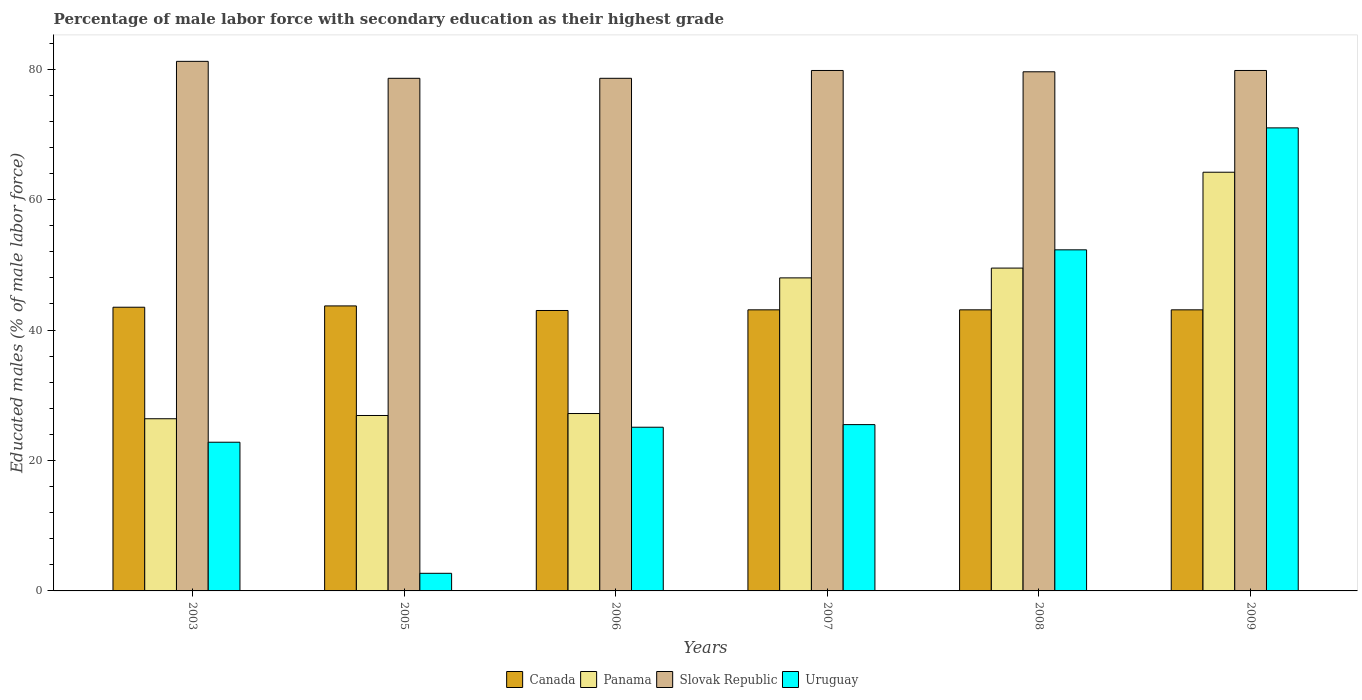How many different coloured bars are there?
Your response must be concise. 4. Are the number of bars per tick equal to the number of legend labels?
Your answer should be compact. Yes. In how many cases, is the number of bars for a given year not equal to the number of legend labels?
Ensure brevity in your answer.  0. What is the percentage of male labor force with secondary education in Panama in 2003?
Provide a short and direct response. 26.4. Across all years, what is the maximum percentage of male labor force with secondary education in Slovak Republic?
Offer a terse response. 81.2. Across all years, what is the minimum percentage of male labor force with secondary education in Slovak Republic?
Your response must be concise. 78.6. In which year was the percentage of male labor force with secondary education in Uruguay minimum?
Offer a terse response. 2005. What is the total percentage of male labor force with secondary education in Canada in the graph?
Your response must be concise. 259.5. What is the difference between the percentage of male labor force with secondary education in Panama in 2006 and that in 2008?
Provide a succinct answer. -22.3. What is the difference between the percentage of male labor force with secondary education in Panama in 2008 and the percentage of male labor force with secondary education in Slovak Republic in 2003?
Keep it short and to the point. -31.7. What is the average percentage of male labor force with secondary education in Slovak Republic per year?
Provide a short and direct response. 79.6. What is the ratio of the percentage of male labor force with secondary education in Slovak Republic in 2003 to that in 2008?
Keep it short and to the point. 1.02. What is the difference between the highest and the second highest percentage of male labor force with secondary education in Panama?
Offer a terse response. 14.7. What is the difference between the highest and the lowest percentage of male labor force with secondary education in Panama?
Provide a short and direct response. 37.8. In how many years, is the percentage of male labor force with secondary education in Panama greater than the average percentage of male labor force with secondary education in Panama taken over all years?
Make the answer very short. 3. What does the 4th bar from the left in 2006 represents?
Ensure brevity in your answer.  Uruguay. What does the 1st bar from the right in 2009 represents?
Your answer should be very brief. Uruguay. How many bars are there?
Your response must be concise. 24. Are all the bars in the graph horizontal?
Ensure brevity in your answer.  No. How many years are there in the graph?
Ensure brevity in your answer.  6. What is the difference between two consecutive major ticks on the Y-axis?
Your answer should be very brief. 20. Does the graph contain grids?
Provide a succinct answer. No. Where does the legend appear in the graph?
Offer a very short reply. Bottom center. How many legend labels are there?
Make the answer very short. 4. What is the title of the graph?
Ensure brevity in your answer.  Percentage of male labor force with secondary education as their highest grade. What is the label or title of the X-axis?
Your answer should be compact. Years. What is the label or title of the Y-axis?
Provide a short and direct response. Educated males (% of male labor force). What is the Educated males (% of male labor force) of Canada in 2003?
Provide a short and direct response. 43.5. What is the Educated males (% of male labor force) in Panama in 2003?
Offer a terse response. 26.4. What is the Educated males (% of male labor force) of Slovak Republic in 2003?
Your response must be concise. 81.2. What is the Educated males (% of male labor force) of Uruguay in 2003?
Make the answer very short. 22.8. What is the Educated males (% of male labor force) of Canada in 2005?
Ensure brevity in your answer.  43.7. What is the Educated males (% of male labor force) in Panama in 2005?
Make the answer very short. 26.9. What is the Educated males (% of male labor force) in Slovak Republic in 2005?
Provide a succinct answer. 78.6. What is the Educated males (% of male labor force) in Uruguay in 2005?
Your answer should be compact. 2.7. What is the Educated males (% of male labor force) in Panama in 2006?
Your answer should be very brief. 27.2. What is the Educated males (% of male labor force) of Slovak Republic in 2006?
Offer a terse response. 78.6. What is the Educated males (% of male labor force) in Uruguay in 2006?
Provide a short and direct response. 25.1. What is the Educated males (% of male labor force) of Canada in 2007?
Give a very brief answer. 43.1. What is the Educated males (% of male labor force) of Panama in 2007?
Provide a succinct answer. 48. What is the Educated males (% of male labor force) of Slovak Republic in 2007?
Offer a very short reply. 79.8. What is the Educated males (% of male labor force) in Uruguay in 2007?
Offer a very short reply. 25.5. What is the Educated males (% of male labor force) in Canada in 2008?
Ensure brevity in your answer.  43.1. What is the Educated males (% of male labor force) in Panama in 2008?
Provide a short and direct response. 49.5. What is the Educated males (% of male labor force) of Slovak Republic in 2008?
Your response must be concise. 79.6. What is the Educated males (% of male labor force) in Uruguay in 2008?
Your answer should be compact. 52.3. What is the Educated males (% of male labor force) of Canada in 2009?
Provide a short and direct response. 43.1. What is the Educated males (% of male labor force) of Panama in 2009?
Your answer should be very brief. 64.2. What is the Educated males (% of male labor force) in Slovak Republic in 2009?
Offer a very short reply. 79.8. Across all years, what is the maximum Educated males (% of male labor force) in Canada?
Offer a very short reply. 43.7. Across all years, what is the maximum Educated males (% of male labor force) in Panama?
Offer a very short reply. 64.2. Across all years, what is the maximum Educated males (% of male labor force) in Slovak Republic?
Your response must be concise. 81.2. Across all years, what is the maximum Educated males (% of male labor force) of Uruguay?
Your answer should be very brief. 71. Across all years, what is the minimum Educated males (% of male labor force) in Canada?
Give a very brief answer. 43. Across all years, what is the minimum Educated males (% of male labor force) of Panama?
Your answer should be compact. 26.4. Across all years, what is the minimum Educated males (% of male labor force) of Slovak Republic?
Offer a very short reply. 78.6. Across all years, what is the minimum Educated males (% of male labor force) in Uruguay?
Provide a succinct answer. 2.7. What is the total Educated males (% of male labor force) of Canada in the graph?
Provide a short and direct response. 259.5. What is the total Educated males (% of male labor force) of Panama in the graph?
Make the answer very short. 242.2. What is the total Educated males (% of male labor force) in Slovak Republic in the graph?
Give a very brief answer. 477.6. What is the total Educated males (% of male labor force) in Uruguay in the graph?
Make the answer very short. 199.4. What is the difference between the Educated males (% of male labor force) in Slovak Republic in 2003 and that in 2005?
Your response must be concise. 2.6. What is the difference between the Educated males (% of male labor force) of Uruguay in 2003 and that in 2005?
Make the answer very short. 20.1. What is the difference between the Educated males (% of male labor force) in Canada in 2003 and that in 2006?
Ensure brevity in your answer.  0.5. What is the difference between the Educated males (% of male labor force) in Panama in 2003 and that in 2006?
Keep it short and to the point. -0.8. What is the difference between the Educated males (% of male labor force) of Slovak Republic in 2003 and that in 2006?
Your response must be concise. 2.6. What is the difference between the Educated males (% of male labor force) in Canada in 2003 and that in 2007?
Ensure brevity in your answer.  0.4. What is the difference between the Educated males (% of male labor force) in Panama in 2003 and that in 2007?
Provide a succinct answer. -21.6. What is the difference between the Educated males (% of male labor force) in Slovak Republic in 2003 and that in 2007?
Offer a very short reply. 1.4. What is the difference between the Educated males (% of male labor force) of Panama in 2003 and that in 2008?
Provide a short and direct response. -23.1. What is the difference between the Educated males (% of male labor force) in Uruguay in 2003 and that in 2008?
Offer a terse response. -29.5. What is the difference between the Educated males (% of male labor force) of Canada in 2003 and that in 2009?
Provide a short and direct response. 0.4. What is the difference between the Educated males (% of male labor force) of Panama in 2003 and that in 2009?
Offer a very short reply. -37.8. What is the difference between the Educated males (% of male labor force) in Uruguay in 2003 and that in 2009?
Give a very brief answer. -48.2. What is the difference between the Educated males (% of male labor force) in Canada in 2005 and that in 2006?
Provide a succinct answer. 0.7. What is the difference between the Educated males (% of male labor force) of Panama in 2005 and that in 2006?
Ensure brevity in your answer.  -0.3. What is the difference between the Educated males (% of male labor force) in Uruguay in 2005 and that in 2006?
Provide a succinct answer. -22.4. What is the difference between the Educated males (% of male labor force) in Canada in 2005 and that in 2007?
Give a very brief answer. 0.6. What is the difference between the Educated males (% of male labor force) in Panama in 2005 and that in 2007?
Give a very brief answer. -21.1. What is the difference between the Educated males (% of male labor force) in Slovak Republic in 2005 and that in 2007?
Your answer should be compact. -1.2. What is the difference between the Educated males (% of male labor force) of Uruguay in 2005 and that in 2007?
Give a very brief answer. -22.8. What is the difference between the Educated males (% of male labor force) in Panama in 2005 and that in 2008?
Your answer should be compact. -22.6. What is the difference between the Educated males (% of male labor force) in Slovak Republic in 2005 and that in 2008?
Your answer should be compact. -1. What is the difference between the Educated males (% of male labor force) in Uruguay in 2005 and that in 2008?
Make the answer very short. -49.6. What is the difference between the Educated males (% of male labor force) in Panama in 2005 and that in 2009?
Provide a short and direct response. -37.3. What is the difference between the Educated males (% of male labor force) of Slovak Republic in 2005 and that in 2009?
Give a very brief answer. -1.2. What is the difference between the Educated males (% of male labor force) in Uruguay in 2005 and that in 2009?
Give a very brief answer. -68.3. What is the difference between the Educated males (% of male labor force) in Canada in 2006 and that in 2007?
Your answer should be compact. -0.1. What is the difference between the Educated males (% of male labor force) in Panama in 2006 and that in 2007?
Your answer should be very brief. -20.8. What is the difference between the Educated males (% of male labor force) in Uruguay in 2006 and that in 2007?
Offer a terse response. -0.4. What is the difference between the Educated males (% of male labor force) of Canada in 2006 and that in 2008?
Keep it short and to the point. -0.1. What is the difference between the Educated males (% of male labor force) of Panama in 2006 and that in 2008?
Your response must be concise. -22.3. What is the difference between the Educated males (% of male labor force) of Uruguay in 2006 and that in 2008?
Provide a short and direct response. -27.2. What is the difference between the Educated males (% of male labor force) in Panama in 2006 and that in 2009?
Make the answer very short. -37. What is the difference between the Educated males (% of male labor force) in Uruguay in 2006 and that in 2009?
Offer a very short reply. -45.9. What is the difference between the Educated males (% of male labor force) of Panama in 2007 and that in 2008?
Your answer should be very brief. -1.5. What is the difference between the Educated males (% of male labor force) in Slovak Republic in 2007 and that in 2008?
Your answer should be very brief. 0.2. What is the difference between the Educated males (% of male labor force) of Uruguay in 2007 and that in 2008?
Your answer should be compact. -26.8. What is the difference between the Educated males (% of male labor force) of Panama in 2007 and that in 2009?
Provide a short and direct response. -16.2. What is the difference between the Educated males (% of male labor force) of Uruguay in 2007 and that in 2009?
Your answer should be very brief. -45.5. What is the difference between the Educated males (% of male labor force) of Panama in 2008 and that in 2009?
Offer a terse response. -14.7. What is the difference between the Educated males (% of male labor force) of Slovak Republic in 2008 and that in 2009?
Provide a short and direct response. -0.2. What is the difference between the Educated males (% of male labor force) in Uruguay in 2008 and that in 2009?
Your answer should be very brief. -18.7. What is the difference between the Educated males (% of male labor force) in Canada in 2003 and the Educated males (% of male labor force) in Slovak Republic in 2005?
Offer a terse response. -35.1. What is the difference between the Educated males (% of male labor force) in Canada in 2003 and the Educated males (% of male labor force) in Uruguay in 2005?
Provide a short and direct response. 40.8. What is the difference between the Educated males (% of male labor force) in Panama in 2003 and the Educated males (% of male labor force) in Slovak Republic in 2005?
Make the answer very short. -52.2. What is the difference between the Educated males (% of male labor force) in Panama in 2003 and the Educated males (% of male labor force) in Uruguay in 2005?
Offer a terse response. 23.7. What is the difference between the Educated males (% of male labor force) of Slovak Republic in 2003 and the Educated males (% of male labor force) of Uruguay in 2005?
Ensure brevity in your answer.  78.5. What is the difference between the Educated males (% of male labor force) of Canada in 2003 and the Educated males (% of male labor force) of Slovak Republic in 2006?
Your response must be concise. -35.1. What is the difference between the Educated males (% of male labor force) of Panama in 2003 and the Educated males (% of male labor force) of Slovak Republic in 2006?
Offer a very short reply. -52.2. What is the difference between the Educated males (% of male labor force) of Slovak Republic in 2003 and the Educated males (% of male labor force) of Uruguay in 2006?
Your response must be concise. 56.1. What is the difference between the Educated males (% of male labor force) in Canada in 2003 and the Educated males (% of male labor force) in Panama in 2007?
Provide a succinct answer. -4.5. What is the difference between the Educated males (% of male labor force) in Canada in 2003 and the Educated males (% of male labor force) in Slovak Republic in 2007?
Offer a very short reply. -36.3. What is the difference between the Educated males (% of male labor force) of Panama in 2003 and the Educated males (% of male labor force) of Slovak Republic in 2007?
Give a very brief answer. -53.4. What is the difference between the Educated males (% of male labor force) of Slovak Republic in 2003 and the Educated males (% of male labor force) of Uruguay in 2007?
Keep it short and to the point. 55.7. What is the difference between the Educated males (% of male labor force) in Canada in 2003 and the Educated males (% of male labor force) in Panama in 2008?
Give a very brief answer. -6. What is the difference between the Educated males (% of male labor force) in Canada in 2003 and the Educated males (% of male labor force) in Slovak Republic in 2008?
Offer a terse response. -36.1. What is the difference between the Educated males (% of male labor force) of Canada in 2003 and the Educated males (% of male labor force) of Uruguay in 2008?
Keep it short and to the point. -8.8. What is the difference between the Educated males (% of male labor force) of Panama in 2003 and the Educated males (% of male labor force) of Slovak Republic in 2008?
Your answer should be compact. -53.2. What is the difference between the Educated males (% of male labor force) of Panama in 2003 and the Educated males (% of male labor force) of Uruguay in 2008?
Keep it short and to the point. -25.9. What is the difference between the Educated males (% of male labor force) of Slovak Republic in 2003 and the Educated males (% of male labor force) of Uruguay in 2008?
Keep it short and to the point. 28.9. What is the difference between the Educated males (% of male labor force) of Canada in 2003 and the Educated males (% of male labor force) of Panama in 2009?
Your response must be concise. -20.7. What is the difference between the Educated males (% of male labor force) of Canada in 2003 and the Educated males (% of male labor force) of Slovak Republic in 2009?
Provide a succinct answer. -36.3. What is the difference between the Educated males (% of male labor force) in Canada in 2003 and the Educated males (% of male labor force) in Uruguay in 2009?
Give a very brief answer. -27.5. What is the difference between the Educated males (% of male labor force) in Panama in 2003 and the Educated males (% of male labor force) in Slovak Republic in 2009?
Ensure brevity in your answer.  -53.4. What is the difference between the Educated males (% of male labor force) of Panama in 2003 and the Educated males (% of male labor force) of Uruguay in 2009?
Provide a short and direct response. -44.6. What is the difference between the Educated males (% of male labor force) in Slovak Republic in 2003 and the Educated males (% of male labor force) in Uruguay in 2009?
Your response must be concise. 10.2. What is the difference between the Educated males (% of male labor force) in Canada in 2005 and the Educated males (% of male labor force) in Panama in 2006?
Offer a terse response. 16.5. What is the difference between the Educated males (% of male labor force) in Canada in 2005 and the Educated males (% of male labor force) in Slovak Republic in 2006?
Make the answer very short. -34.9. What is the difference between the Educated males (% of male labor force) in Canada in 2005 and the Educated males (% of male labor force) in Uruguay in 2006?
Make the answer very short. 18.6. What is the difference between the Educated males (% of male labor force) in Panama in 2005 and the Educated males (% of male labor force) in Slovak Republic in 2006?
Offer a very short reply. -51.7. What is the difference between the Educated males (% of male labor force) of Slovak Republic in 2005 and the Educated males (% of male labor force) of Uruguay in 2006?
Your answer should be very brief. 53.5. What is the difference between the Educated males (% of male labor force) in Canada in 2005 and the Educated males (% of male labor force) in Slovak Republic in 2007?
Keep it short and to the point. -36.1. What is the difference between the Educated males (% of male labor force) of Panama in 2005 and the Educated males (% of male labor force) of Slovak Republic in 2007?
Your response must be concise. -52.9. What is the difference between the Educated males (% of male labor force) in Panama in 2005 and the Educated males (% of male labor force) in Uruguay in 2007?
Offer a very short reply. 1.4. What is the difference between the Educated males (% of male labor force) in Slovak Republic in 2005 and the Educated males (% of male labor force) in Uruguay in 2007?
Your response must be concise. 53.1. What is the difference between the Educated males (% of male labor force) of Canada in 2005 and the Educated males (% of male labor force) of Slovak Republic in 2008?
Offer a very short reply. -35.9. What is the difference between the Educated males (% of male labor force) of Panama in 2005 and the Educated males (% of male labor force) of Slovak Republic in 2008?
Offer a terse response. -52.7. What is the difference between the Educated males (% of male labor force) of Panama in 2005 and the Educated males (% of male labor force) of Uruguay in 2008?
Offer a very short reply. -25.4. What is the difference between the Educated males (% of male labor force) in Slovak Republic in 2005 and the Educated males (% of male labor force) in Uruguay in 2008?
Your answer should be compact. 26.3. What is the difference between the Educated males (% of male labor force) in Canada in 2005 and the Educated males (% of male labor force) in Panama in 2009?
Make the answer very short. -20.5. What is the difference between the Educated males (% of male labor force) in Canada in 2005 and the Educated males (% of male labor force) in Slovak Republic in 2009?
Your answer should be very brief. -36.1. What is the difference between the Educated males (% of male labor force) of Canada in 2005 and the Educated males (% of male labor force) of Uruguay in 2009?
Provide a short and direct response. -27.3. What is the difference between the Educated males (% of male labor force) of Panama in 2005 and the Educated males (% of male labor force) of Slovak Republic in 2009?
Keep it short and to the point. -52.9. What is the difference between the Educated males (% of male labor force) in Panama in 2005 and the Educated males (% of male labor force) in Uruguay in 2009?
Provide a short and direct response. -44.1. What is the difference between the Educated males (% of male labor force) of Slovak Republic in 2005 and the Educated males (% of male labor force) of Uruguay in 2009?
Give a very brief answer. 7.6. What is the difference between the Educated males (% of male labor force) in Canada in 2006 and the Educated males (% of male labor force) in Panama in 2007?
Your response must be concise. -5. What is the difference between the Educated males (% of male labor force) of Canada in 2006 and the Educated males (% of male labor force) of Slovak Republic in 2007?
Your answer should be very brief. -36.8. What is the difference between the Educated males (% of male labor force) in Canada in 2006 and the Educated males (% of male labor force) in Uruguay in 2007?
Offer a very short reply. 17.5. What is the difference between the Educated males (% of male labor force) of Panama in 2006 and the Educated males (% of male labor force) of Slovak Republic in 2007?
Keep it short and to the point. -52.6. What is the difference between the Educated males (% of male labor force) of Panama in 2006 and the Educated males (% of male labor force) of Uruguay in 2007?
Keep it short and to the point. 1.7. What is the difference between the Educated males (% of male labor force) of Slovak Republic in 2006 and the Educated males (% of male labor force) of Uruguay in 2007?
Give a very brief answer. 53.1. What is the difference between the Educated males (% of male labor force) of Canada in 2006 and the Educated males (% of male labor force) of Panama in 2008?
Make the answer very short. -6.5. What is the difference between the Educated males (% of male labor force) of Canada in 2006 and the Educated males (% of male labor force) of Slovak Republic in 2008?
Give a very brief answer. -36.6. What is the difference between the Educated males (% of male labor force) of Panama in 2006 and the Educated males (% of male labor force) of Slovak Republic in 2008?
Your answer should be very brief. -52.4. What is the difference between the Educated males (% of male labor force) in Panama in 2006 and the Educated males (% of male labor force) in Uruguay in 2008?
Your answer should be compact. -25.1. What is the difference between the Educated males (% of male labor force) of Slovak Republic in 2006 and the Educated males (% of male labor force) of Uruguay in 2008?
Offer a very short reply. 26.3. What is the difference between the Educated males (% of male labor force) in Canada in 2006 and the Educated males (% of male labor force) in Panama in 2009?
Provide a short and direct response. -21.2. What is the difference between the Educated males (% of male labor force) of Canada in 2006 and the Educated males (% of male labor force) of Slovak Republic in 2009?
Make the answer very short. -36.8. What is the difference between the Educated males (% of male labor force) of Panama in 2006 and the Educated males (% of male labor force) of Slovak Republic in 2009?
Give a very brief answer. -52.6. What is the difference between the Educated males (% of male labor force) in Panama in 2006 and the Educated males (% of male labor force) in Uruguay in 2009?
Offer a terse response. -43.8. What is the difference between the Educated males (% of male labor force) in Canada in 2007 and the Educated males (% of male labor force) in Panama in 2008?
Provide a succinct answer. -6.4. What is the difference between the Educated males (% of male labor force) of Canada in 2007 and the Educated males (% of male labor force) of Slovak Republic in 2008?
Offer a very short reply. -36.5. What is the difference between the Educated males (% of male labor force) in Panama in 2007 and the Educated males (% of male labor force) in Slovak Republic in 2008?
Offer a very short reply. -31.6. What is the difference between the Educated males (% of male labor force) in Panama in 2007 and the Educated males (% of male labor force) in Uruguay in 2008?
Offer a terse response. -4.3. What is the difference between the Educated males (% of male labor force) of Slovak Republic in 2007 and the Educated males (% of male labor force) of Uruguay in 2008?
Provide a short and direct response. 27.5. What is the difference between the Educated males (% of male labor force) of Canada in 2007 and the Educated males (% of male labor force) of Panama in 2009?
Keep it short and to the point. -21.1. What is the difference between the Educated males (% of male labor force) in Canada in 2007 and the Educated males (% of male labor force) in Slovak Republic in 2009?
Your response must be concise. -36.7. What is the difference between the Educated males (% of male labor force) of Canada in 2007 and the Educated males (% of male labor force) of Uruguay in 2009?
Provide a succinct answer. -27.9. What is the difference between the Educated males (% of male labor force) in Panama in 2007 and the Educated males (% of male labor force) in Slovak Republic in 2009?
Your response must be concise. -31.8. What is the difference between the Educated males (% of male labor force) in Slovak Republic in 2007 and the Educated males (% of male labor force) in Uruguay in 2009?
Your response must be concise. 8.8. What is the difference between the Educated males (% of male labor force) of Canada in 2008 and the Educated males (% of male labor force) of Panama in 2009?
Offer a terse response. -21.1. What is the difference between the Educated males (% of male labor force) of Canada in 2008 and the Educated males (% of male labor force) of Slovak Republic in 2009?
Your answer should be very brief. -36.7. What is the difference between the Educated males (% of male labor force) in Canada in 2008 and the Educated males (% of male labor force) in Uruguay in 2009?
Provide a short and direct response. -27.9. What is the difference between the Educated males (% of male labor force) in Panama in 2008 and the Educated males (% of male labor force) in Slovak Republic in 2009?
Your response must be concise. -30.3. What is the difference between the Educated males (% of male labor force) in Panama in 2008 and the Educated males (% of male labor force) in Uruguay in 2009?
Your answer should be very brief. -21.5. What is the difference between the Educated males (% of male labor force) in Slovak Republic in 2008 and the Educated males (% of male labor force) in Uruguay in 2009?
Make the answer very short. 8.6. What is the average Educated males (% of male labor force) in Canada per year?
Provide a succinct answer. 43.25. What is the average Educated males (% of male labor force) in Panama per year?
Offer a very short reply. 40.37. What is the average Educated males (% of male labor force) in Slovak Republic per year?
Your response must be concise. 79.6. What is the average Educated males (% of male labor force) in Uruguay per year?
Give a very brief answer. 33.23. In the year 2003, what is the difference between the Educated males (% of male labor force) of Canada and Educated males (% of male labor force) of Slovak Republic?
Offer a very short reply. -37.7. In the year 2003, what is the difference between the Educated males (% of male labor force) in Canada and Educated males (% of male labor force) in Uruguay?
Provide a short and direct response. 20.7. In the year 2003, what is the difference between the Educated males (% of male labor force) of Panama and Educated males (% of male labor force) of Slovak Republic?
Provide a succinct answer. -54.8. In the year 2003, what is the difference between the Educated males (% of male labor force) in Panama and Educated males (% of male labor force) in Uruguay?
Give a very brief answer. 3.6. In the year 2003, what is the difference between the Educated males (% of male labor force) of Slovak Republic and Educated males (% of male labor force) of Uruguay?
Your response must be concise. 58.4. In the year 2005, what is the difference between the Educated males (% of male labor force) in Canada and Educated males (% of male labor force) in Panama?
Make the answer very short. 16.8. In the year 2005, what is the difference between the Educated males (% of male labor force) in Canada and Educated males (% of male labor force) in Slovak Republic?
Your answer should be compact. -34.9. In the year 2005, what is the difference between the Educated males (% of male labor force) in Panama and Educated males (% of male labor force) in Slovak Republic?
Give a very brief answer. -51.7. In the year 2005, what is the difference between the Educated males (% of male labor force) of Panama and Educated males (% of male labor force) of Uruguay?
Make the answer very short. 24.2. In the year 2005, what is the difference between the Educated males (% of male labor force) in Slovak Republic and Educated males (% of male labor force) in Uruguay?
Make the answer very short. 75.9. In the year 2006, what is the difference between the Educated males (% of male labor force) of Canada and Educated males (% of male labor force) of Panama?
Your answer should be compact. 15.8. In the year 2006, what is the difference between the Educated males (% of male labor force) of Canada and Educated males (% of male labor force) of Slovak Republic?
Give a very brief answer. -35.6. In the year 2006, what is the difference between the Educated males (% of male labor force) in Panama and Educated males (% of male labor force) in Slovak Republic?
Offer a very short reply. -51.4. In the year 2006, what is the difference between the Educated males (% of male labor force) in Slovak Republic and Educated males (% of male labor force) in Uruguay?
Keep it short and to the point. 53.5. In the year 2007, what is the difference between the Educated males (% of male labor force) of Canada and Educated males (% of male labor force) of Panama?
Keep it short and to the point. -4.9. In the year 2007, what is the difference between the Educated males (% of male labor force) in Canada and Educated males (% of male labor force) in Slovak Republic?
Your response must be concise. -36.7. In the year 2007, what is the difference between the Educated males (% of male labor force) in Panama and Educated males (% of male labor force) in Slovak Republic?
Provide a short and direct response. -31.8. In the year 2007, what is the difference between the Educated males (% of male labor force) in Slovak Republic and Educated males (% of male labor force) in Uruguay?
Offer a terse response. 54.3. In the year 2008, what is the difference between the Educated males (% of male labor force) of Canada and Educated males (% of male labor force) of Panama?
Keep it short and to the point. -6.4. In the year 2008, what is the difference between the Educated males (% of male labor force) in Canada and Educated males (% of male labor force) in Slovak Republic?
Provide a short and direct response. -36.5. In the year 2008, what is the difference between the Educated males (% of male labor force) in Canada and Educated males (% of male labor force) in Uruguay?
Provide a succinct answer. -9.2. In the year 2008, what is the difference between the Educated males (% of male labor force) of Panama and Educated males (% of male labor force) of Slovak Republic?
Offer a terse response. -30.1. In the year 2008, what is the difference between the Educated males (% of male labor force) in Slovak Republic and Educated males (% of male labor force) in Uruguay?
Make the answer very short. 27.3. In the year 2009, what is the difference between the Educated males (% of male labor force) of Canada and Educated males (% of male labor force) of Panama?
Ensure brevity in your answer.  -21.1. In the year 2009, what is the difference between the Educated males (% of male labor force) of Canada and Educated males (% of male labor force) of Slovak Republic?
Your answer should be compact. -36.7. In the year 2009, what is the difference between the Educated males (% of male labor force) in Canada and Educated males (% of male labor force) in Uruguay?
Keep it short and to the point. -27.9. In the year 2009, what is the difference between the Educated males (% of male labor force) of Panama and Educated males (% of male labor force) of Slovak Republic?
Offer a terse response. -15.6. In the year 2009, what is the difference between the Educated males (% of male labor force) of Panama and Educated males (% of male labor force) of Uruguay?
Your answer should be compact. -6.8. In the year 2009, what is the difference between the Educated males (% of male labor force) in Slovak Republic and Educated males (% of male labor force) in Uruguay?
Provide a short and direct response. 8.8. What is the ratio of the Educated males (% of male labor force) in Canada in 2003 to that in 2005?
Your answer should be very brief. 1. What is the ratio of the Educated males (% of male labor force) of Panama in 2003 to that in 2005?
Provide a short and direct response. 0.98. What is the ratio of the Educated males (% of male labor force) of Slovak Republic in 2003 to that in 2005?
Keep it short and to the point. 1.03. What is the ratio of the Educated males (% of male labor force) of Uruguay in 2003 to that in 2005?
Provide a succinct answer. 8.44. What is the ratio of the Educated males (% of male labor force) in Canada in 2003 to that in 2006?
Ensure brevity in your answer.  1.01. What is the ratio of the Educated males (% of male labor force) of Panama in 2003 to that in 2006?
Your answer should be compact. 0.97. What is the ratio of the Educated males (% of male labor force) of Slovak Republic in 2003 to that in 2006?
Your answer should be very brief. 1.03. What is the ratio of the Educated males (% of male labor force) in Uruguay in 2003 to that in 2006?
Provide a short and direct response. 0.91. What is the ratio of the Educated males (% of male labor force) of Canada in 2003 to that in 2007?
Offer a terse response. 1.01. What is the ratio of the Educated males (% of male labor force) of Panama in 2003 to that in 2007?
Offer a terse response. 0.55. What is the ratio of the Educated males (% of male labor force) of Slovak Republic in 2003 to that in 2007?
Provide a short and direct response. 1.02. What is the ratio of the Educated males (% of male labor force) in Uruguay in 2003 to that in 2007?
Provide a short and direct response. 0.89. What is the ratio of the Educated males (% of male labor force) in Canada in 2003 to that in 2008?
Provide a short and direct response. 1.01. What is the ratio of the Educated males (% of male labor force) in Panama in 2003 to that in 2008?
Keep it short and to the point. 0.53. What is the ratio of the Educated males (% of male labor force) in Slovak Republic in 2003 to that in 2008?
Keep it short and to the point. 1.02. What is the ratio of the Educated males (% of male labor force) of Uruguay in 2003 to that in 2008?
Offer a terse response. 0.44. What is the ratio of the Educated males (% of male labor force) of Canada in 2003 to that in 2009?
Your answer should be very brief. 1.01. What is the ratio of the Educated males (% of male labor force) in Panama in 2003 to that in 2009?
Provide a succinct answer. 0.41. What is the ratio of the Educated males (% of male labor force) in Slovak Republic in 2003 to that in 2009?
Offer a very short reply. 1.02. What is the ratio of the Educated males (% of male labor force) of Uruguay in 2003 to that in 2009?
Make the answer very short. 0.32. What is the ratio of the Educated males (% of male labor force) in Canada in 2005 to that in 2006?
Your answer should be very brief. 1.02. What is the ratio of the Educated males (% of male labor force) in Uruguay in 2005 to that in 2006?
Offer a very short reply. 0.11. What is the ratio of the Educated males (% of male labor force) in Canada in 2005 to that in 2007?
Keep it short and to the point. 1.01. What is the ratio of the Educated males (% of male labor force) in Panama in 2005 to that in 2007?
Provide a short and direct response. 0.56. What is the ratio of the Educated males (% of male labor force) in Slovak Republic in 2005 to that in 2007?
Keep it short and to the point. 0.98. What is the ratio of the Educated males (% of male labor force) of Uruguay in 2005 to that in 2007?
Your answer should be very brief. 0.11. What is the ratio of the Educated males (% of male labor force) of Canada in 2005 to that in 2008?
Your answer should be very brief. 1.01. What is the ratio of the Educated males (% of male labor force) in Panama in 2005 to that in 2008?
Keep it short and to the point. 0.54. What is the ratio of the Educated males (% of male labor force) in Slovak Republic in 2005 to that in 2008?
Keep it short and to the point. 0.99. What is the ratio of the Educated males (% of male labor force) in Uruguay in 2005 to that in 2008?
Offer a terse response. 0.05. What is the ratio of the Educated males (% of male labor force) in Canada in 2005 to that in 2009?
Give a very brief answer. 1.01. What is the ratio of the Educated males (% of male labor force) in Panama in 2005 to that in 2009?
Your answer should be compact. 0.42. What is the ratio of the Educated males (% of male labor force) of Slovak Republic in 2005 to that in 2009?
Offer a very short reply. 0.98. What is the ratio of the Educated males (% of male labor force) of Uruguay in 2005 to that in 2009?
Provide a succinct answer. 0.04. What is the ratio of the Educated males (% of male labor force) of Panama in 2006 to that in 2007?
Your answer should be very brief. 0.57. What is the ratio of the Educated males (% of male labor force) of Slovak Republic in 2006 to that in 2007?
Provide a short and direct response. 0.98. What is the ratio of the Educated males (% of male labor force) in Uruguay in 2006 to that in 2007?
Provide a short and direct response. 0.98. What is the ratio of the Educated males (% of male labor force) in Canada in 2006 to that in 2008?
Your answer should be compact. 1. What is the ratio of the Educated males (% of male labor force) in Panama in 2006 to that in 2008?
Give a very brief answer. 0.55. What is the ratio of the Educated males (% of male labor force) in Slovak Republic in 2006 to that in 2008?
Provide a succinct answer. 0.99. What is the ratio of the Educated males (% of male labor force) of Uruguay in 2006 to that in 2008?
Provide a short and direct response. 0.48. What is the ratio of the Educated males (% of male labor force) in Panama in 2006 to that in 2009?
Make the answer very short. 0.42. What is the ratio of the Educated males (% of male labor force) of Slovak Republic in 2006 to that in 2009?
Offer a terse response. 0.98. What is the ratio of the Educated males (% of male labor force) of Uruguay in 2006 to that in 2009?
Your answer should be very brief. 0.35. What is the ratio of the Educated males (% of male labor force) of Canada in 2007 to that in 2008?
Provide a short and direct response. 1. What is the ratio of the Educated males (% of male labor force) in Panama in 2007 to that in 2008?
Your answer should be very brief. 0.97. What is the ratio of the Educated males (% of male labor force) of Uruguay in 2007 to that in 2008?
Give a very brief answer. 0.49. What is the ratio of the Educated males (% of male labor force) in Panama in 2007 to that in 2009?
Your answer should be compact. 0.75. What is the ratio of the Educated males (% of male labor force) of Uruguay in 2007 to that in 2009?
Your answer should be very brief. 0.36. What is the ratio of the Educated males (% of male labor force) in Panama in 2008 to that in 2009?
Offer a terse response. 0.77. What is the ratio of the Educated males (% of male labor force) in Slovak Republic in 2008 to that in 2009?
Make the answer very short. 1. What is the ratio of the Educated males (% of male labor force) in Uruguay in 2008 to that in 2009?
Give a very brief answer. 0.74. What is the difference between the highest and the second highest Educated males (% of male labor force) in Canada?
Your answer should be very brief. 0.2. What is the difference between the highest and the lowest Educated males (% of male labor force) in Panama?
Provide a succinct answer. 37.8. What is the difference between the highest and the lowest Educated males (% of male labor force) of Uruguay?
Ensure brevity in your answer.  68.3. 